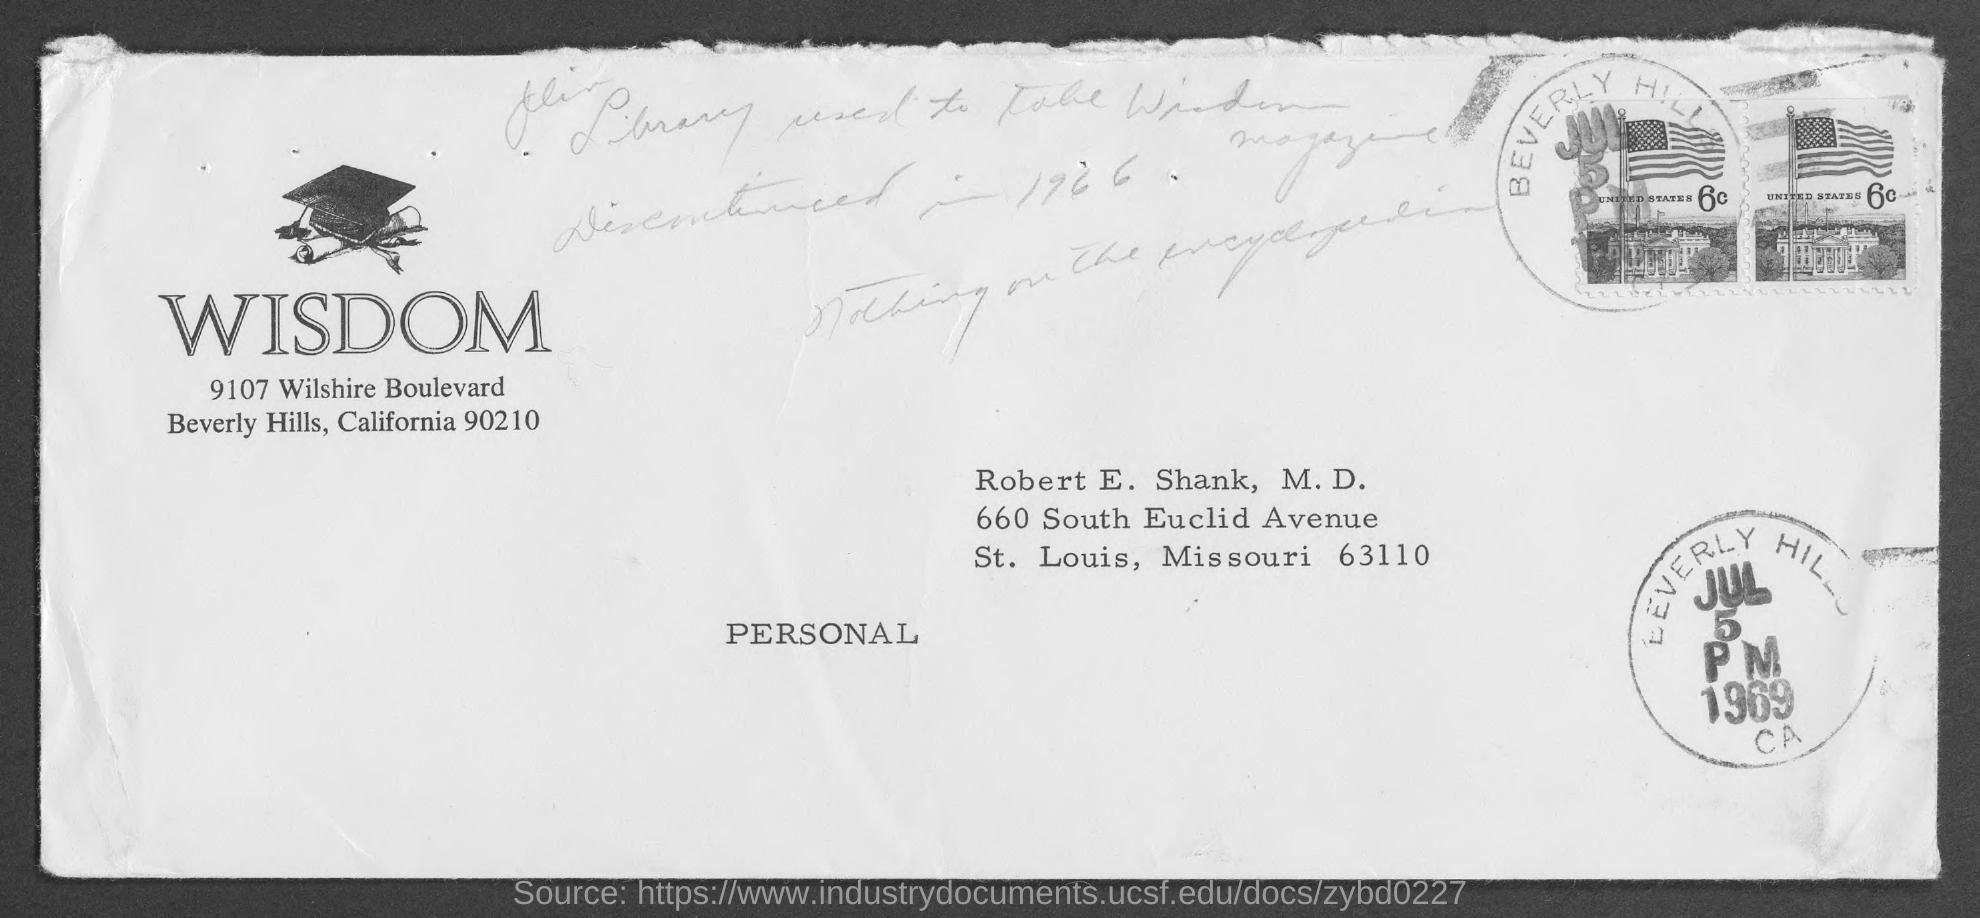To whom is the letter addressed?
Your response must be concise. Robert E. Shank, M.D. 